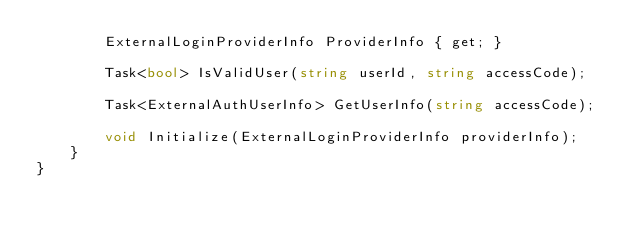Convert code to text. <code><loc_0><loc_0><loc_500><loc_500><_C#_>        ExternalLoginProviderInfo ProviderInfo { get; }

        Task<bool> IsValidUser(string userId, string accessCode);

        Task<ExternalAuthUserInfo> GetUserInfo(string accessCode);

        void Initialize(ExternalLoginProviderInfo providerInfo);
    }
}
</code> 